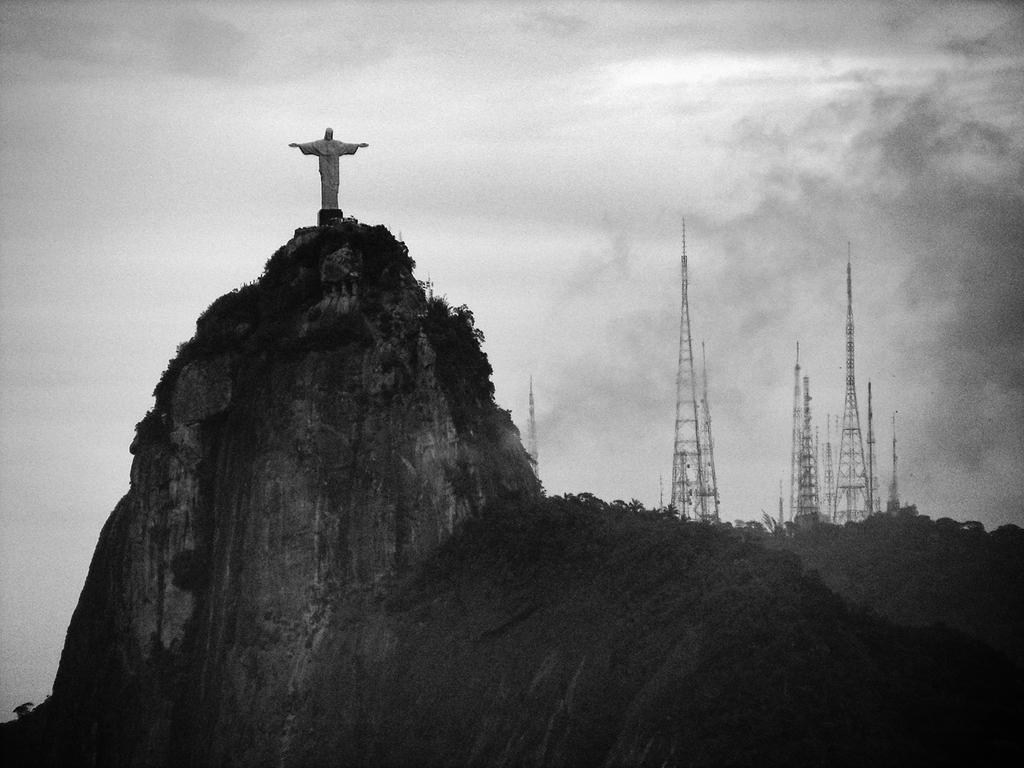What is the main feature of the image? There is a mountain in the image. What is located on the mountain? There is a statue on the mountain. What can be seen on the right side of the image? There are towers on the right side of the image. What is visible at the top of the image? The sky is visible at the top of the image. How would you describe the sky in the image? The sky is cloudy in the image. Can you tell me what type of detail your aunt added to the mountain in the image? There is no mention of an aunt or any additional details added to the mountain in the image. 